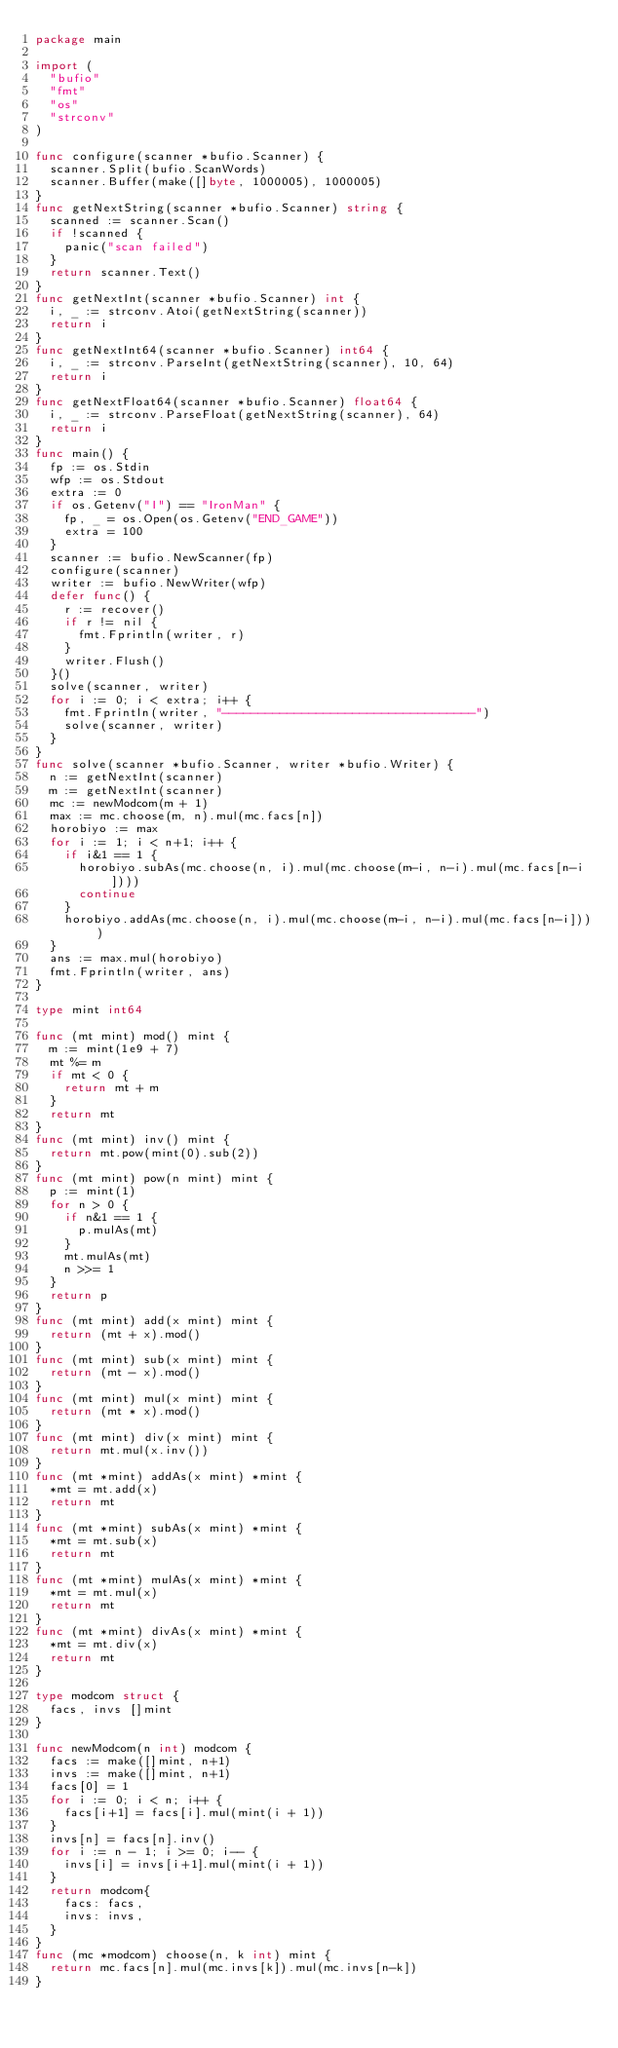<code> <loc_0><loc_0><loc_500><loc_500><_Go_>package main

import (
	"bufio"
	"fmt"
	"os"
	"strconv"
)

func configure(scanner *bufio.Scanner) {
	scanner.Split(bufio.ScanWords)
	scanner.Buffer(make([]byte, 1000005), 1000005)
}
func getNextString(scanner *bufio.Scanner) string {
	scanned := scanner.Scan()
	if !scanned {
		panic("scan failed")
	}
	return scanner.Text()
}
func getNextInt(scanner *bufio.Scanner) int {
	i, _ := strconv.Atoi(getNextString(scanner))
	return i
}
func getNextInt64(scanner *bufio.Scanner) int64 {
	i, _ := strconv.ParseInt(getNextString(scanner), 10, 64)
	return i
}
func getNextFloat64(scanner *bufio.Scanner) float64 {
	i, _ := strconv.ParseFloat(getNextString(scanner), 64)
	return i
}
func main() {
	fp := os.Stdin
	wfp := os.Stdout
	extra := 0
	if os.Getenv("I") == "IronMan" {
		fp, _ = os.Open(os.Getenv("END_GAME"))
		extra = 100
	}
	scanner := bufio.NewScanner(fp)
	configure(scanner)
	writer := bufio.NewWriter(wfp)
	defer func() {
		r := recover()
		if r != nil {
			fmt.Fprintln(writer, r)
		}
		writer.Flush()
	}()
	solve(scanner, writer)
	for i := 0; i < extra; i++ {
		fmt.Fprintln(writer, "-----------------------------------")
		solve(scanner, writer)
	}
}
func solve(scanner *bufio.Scanner, writer *bufio.Writer) {
	n := getNextInt(scanner)
	m := getNextInt(scanner)
	mc := newModcom(m + 1)
	max := mc.choose(m, n).mul(mc.facs[n])
	horobiyo := max
	for i := 1; i < n+1; i++ {
		if i&1 == 1 {
			horobiyo.subAs(mc.choose(n, i).mul(mc.choose(m-i, n-i).mul(mc.facs[n-i])))
			continue
		}
		horobiyo.addAs(mc.choose(n, i).mul(mc.choose(m-i, n-i).mul(mc.facs[n-i])))
	}
	ans := max.mul(horobiyo)
	fmt.Fprintln(writer, ans)
}

type mint int64

func (mt mint) mod() mint {
	m := mint(1e9 + 7)
	mt %= m
	if mt < 0 {
		return mt + m
	}
	return mt
}
func (mt mint) inv() mint {
	return mt.pow(mint(0).sub(2))
}
func (mt mint) pow(n mint) mint {
	p := mint(1)
	for n > 0 {
		if n&1 == 1 {
			p.mulAs(mt)
		}
		mt.mulAs(mt)
		n >>= 1
	}
	return p
}
func (mt mint) add(x mint) mint {
	return (mt + x).mod()
}
func (mt mint) sub(x mint) mint {
	return (mt - x).mod()
}
func (mt mint) mul(x mint) mint {
	return (mt * x).mod()
}
func (mt mint) div(x mint) mint {
	return mt.mul(x.inv())
}
func (mt *mint) addAs(x mint) *mint {
	*mt = mt.add(x)
	return mt
}
func (mt *mint) subAs(x mint) *mint {
	*mt = mt.sub(x)
	return mt
}
func (mt *mint) mulAs(x mint) *mint {
	*mt = mt.mul(x)
	return mt
}
func (mt *mint) divAs(x mint) *mint {
	*mt = mt.div(x)
	return mt
}

type modcom struct {
	facs, invs []mint
}

func newModcom(n int) modcom {
	facs := make([]mint, n+1)
	invs := make([]mint, n+1)
	facs[0] = 1
	for i := 0; i < n; i++ {
		facs[i+1] = facs[i].mul(mint(i + 1))
	}
	invs[n] = facs[n].inv()
	for i := n - 1; i >= 0; i-- {
		invs[i] = invs[i+1].mul(mint(i + 1))
	}
	return modcom{
		facs: facs,
		invs: invs,
	}
}
func (mc *modcom) choose(n, k int) mint {
	return mc.facs[n].mul(mc.invs[k]).mul(mc.invs[n-k])
}
</code> 